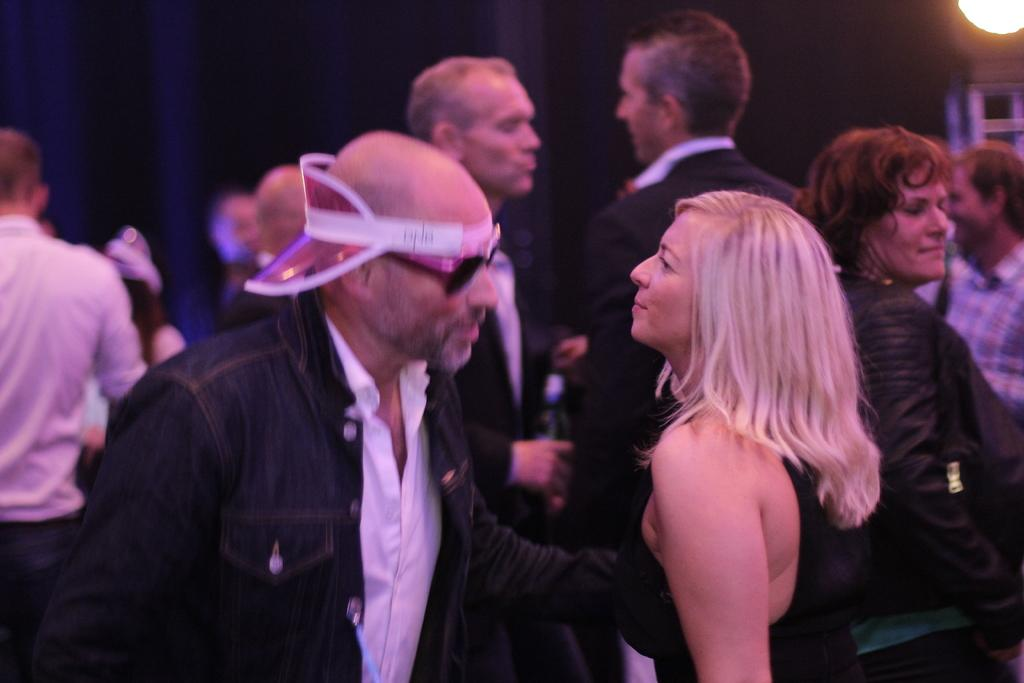What are the people in the image doing? The people in the image are dancing. Where is the dancing taking place? The dancing is taking place inside a room. Can you describe any specific features of the room? There is a light attached to a pole in the image. What type of mine can be seen in the image? There is no mine present in the image; it features people dancing inside a room. What smell is associated with the dancing in the image? The image does not provide any information about smells, so it cannot be determined from the image. 